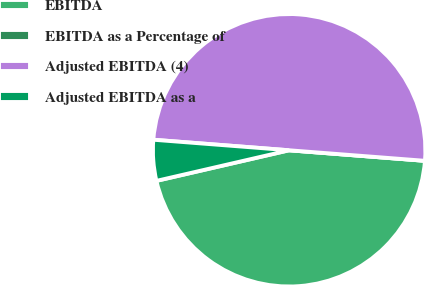<chart> <loc_0><loc_0><loc_500><loc_500><pie_chart><fcel>EBITDA<fcel>EBITDA as a Percentage of<fcel>Adjusted EBITDA (4)<fcel>Adjusted EBITDA as a<nl><fcel>45.16%<fcel>0.0%<fcel>50.0%<fcel>4.84%<nl></chart> 